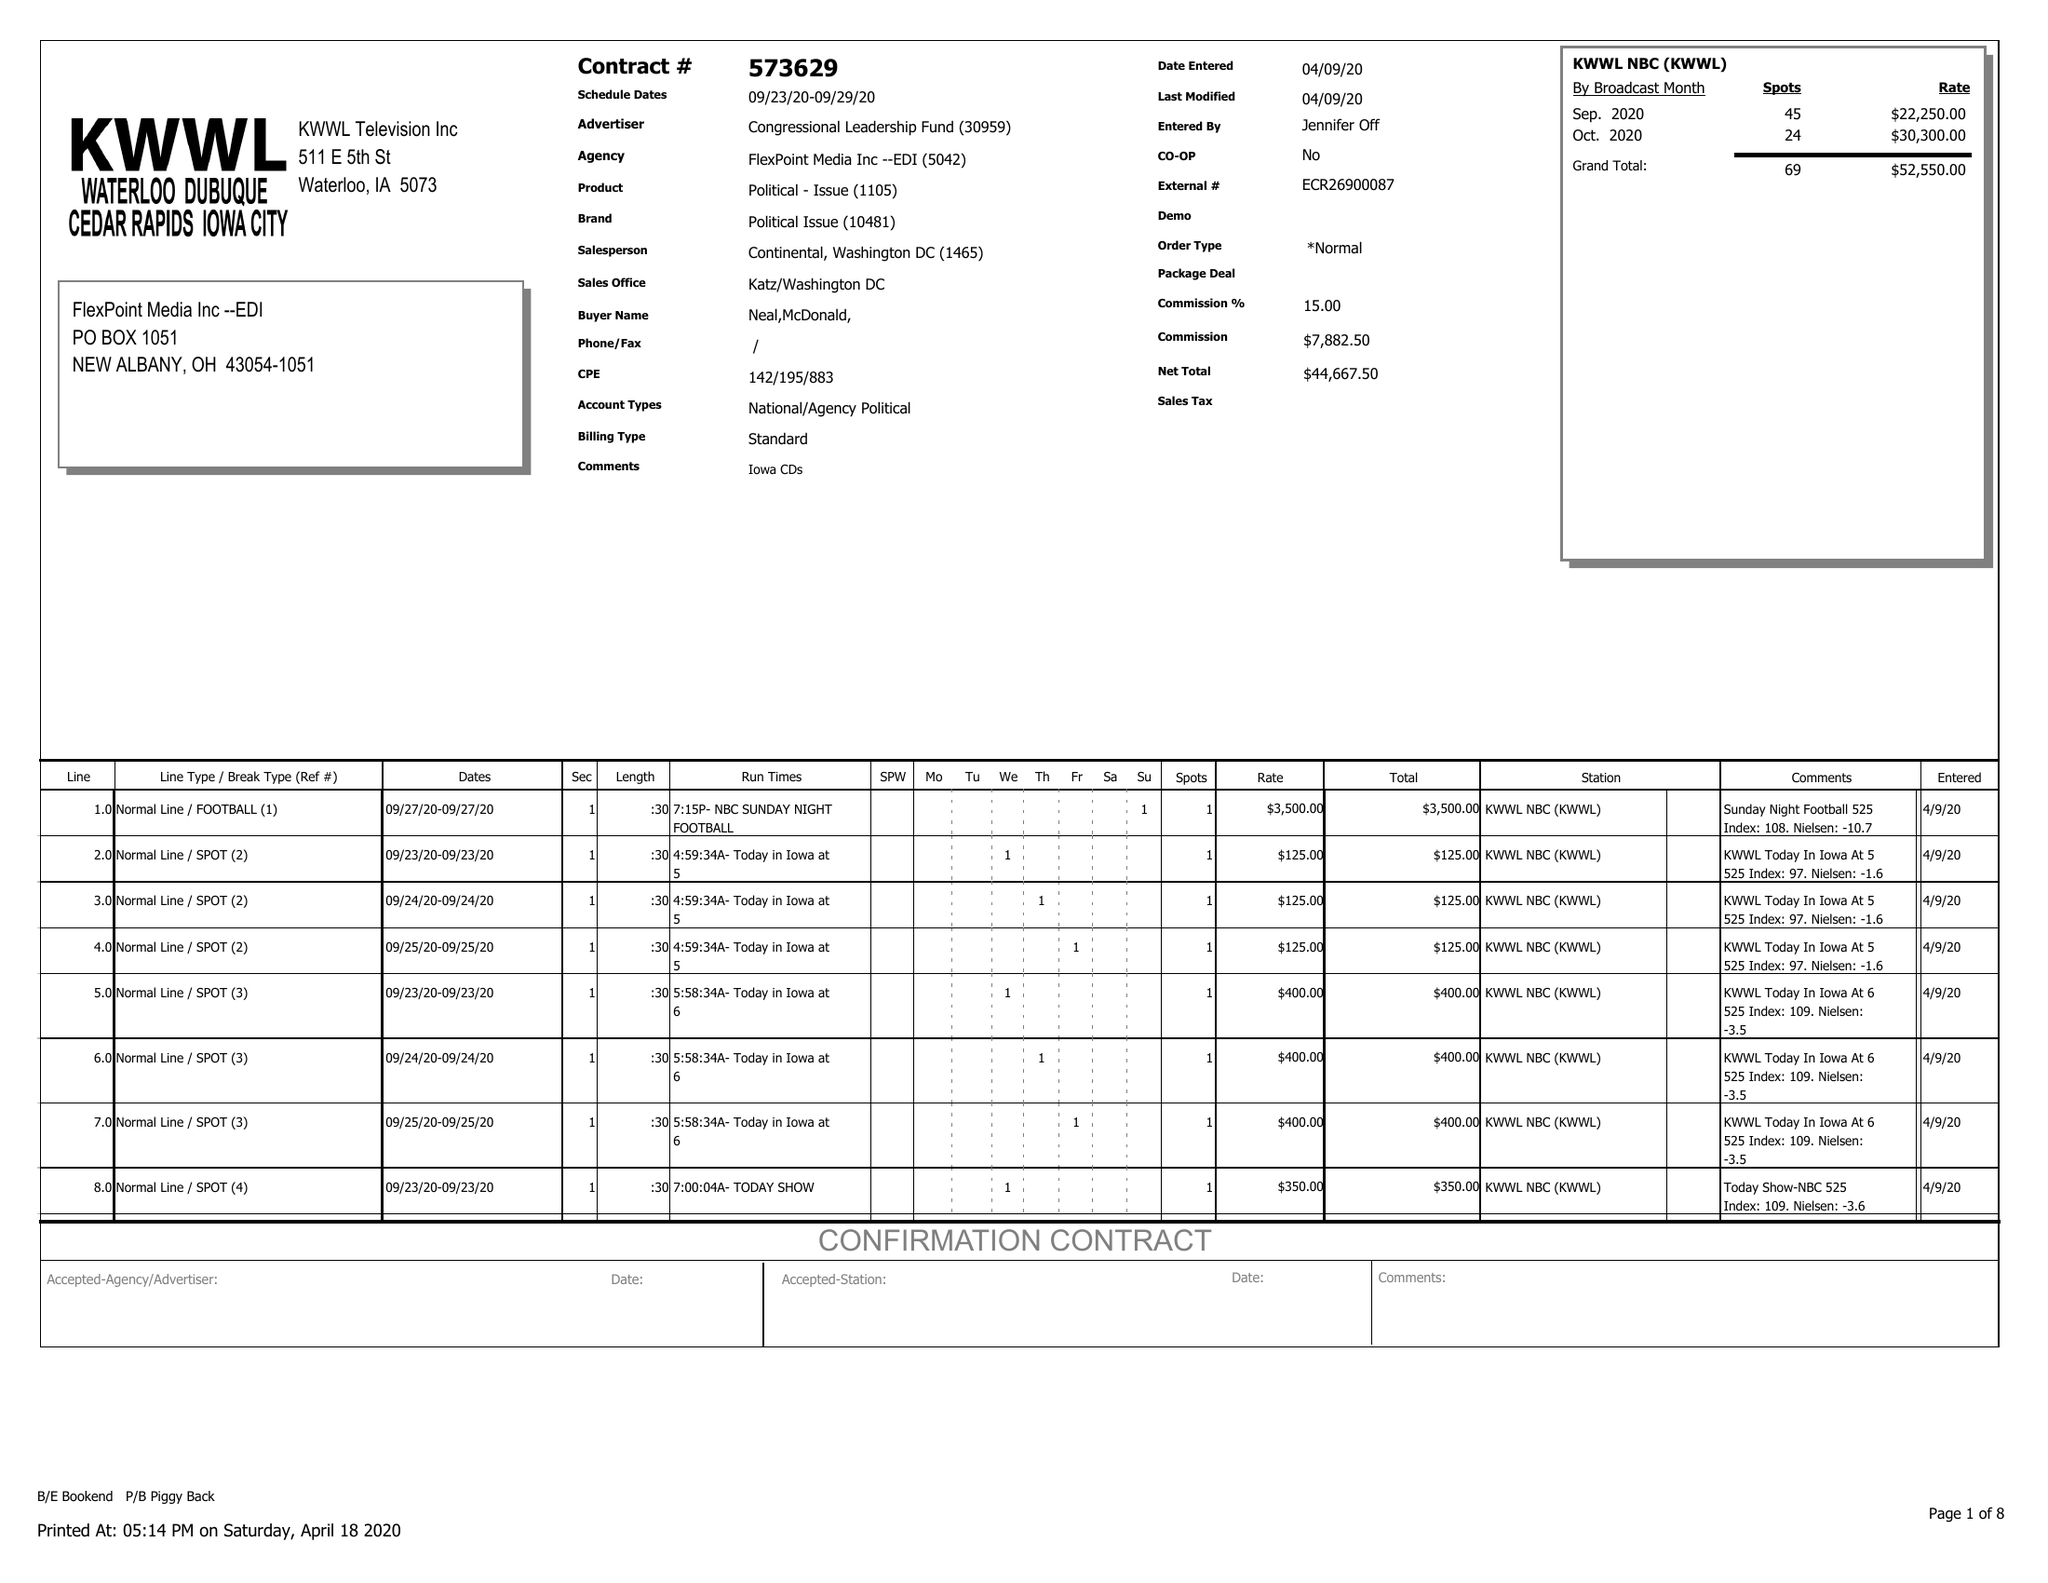What is the value for the advertiser?
Answer the question using a single word or phrase. CONGRESSIONAL LEADERSHIP FUND 